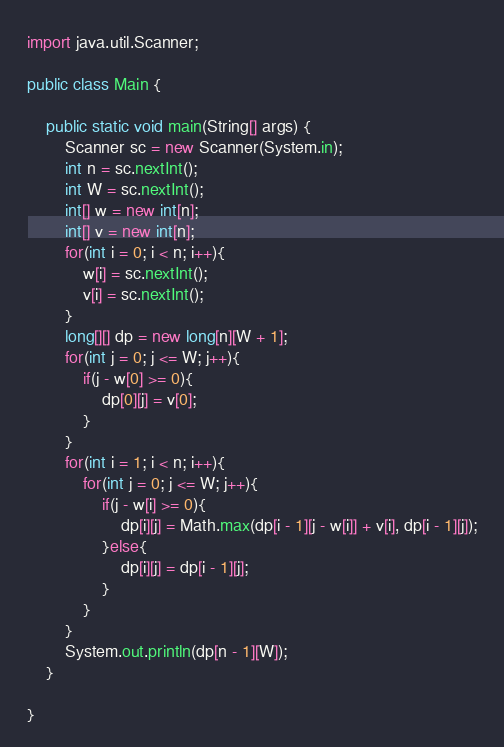<code> <loc_0><loc_0><loc_500><loc_500><_Java_>import java.util.Scanner;

public class Main {

	public static void main(String[] args) {
		Scanner sc = new Scanner(System.in);
		int n = sc.nextInt();
		int W = sc.nextInt();
		int[] w = new int[n];
		int[] v = new int[n];
		for(int i = 0; i < n; i++){
		    w[i] = sc.nextInt();
		    v[i] = sc.nextInt();
		}
		long[][] dp = new long[n][W + 1];
		for(int j = 0; j <= W; j++){
		    if(j - w[0] >= 0){
		        dp[0][j] = v[0];
		    }
		}
		for(int i = 1; i < n; i++){
		    for(int j = 0; j <= W; j++){
		        if(j - w[i] >= 0){
		            dp[i][j] = Math.max(dp[i - 1][j - w[i]] + v[i], dp[i - 1][j]);
		        }else{
		            dp[i][j] = dp[i - 1][j];
		        }
		    }
		}
		System.out.println(dp[n - 1][W]);
	}

}
</code> 